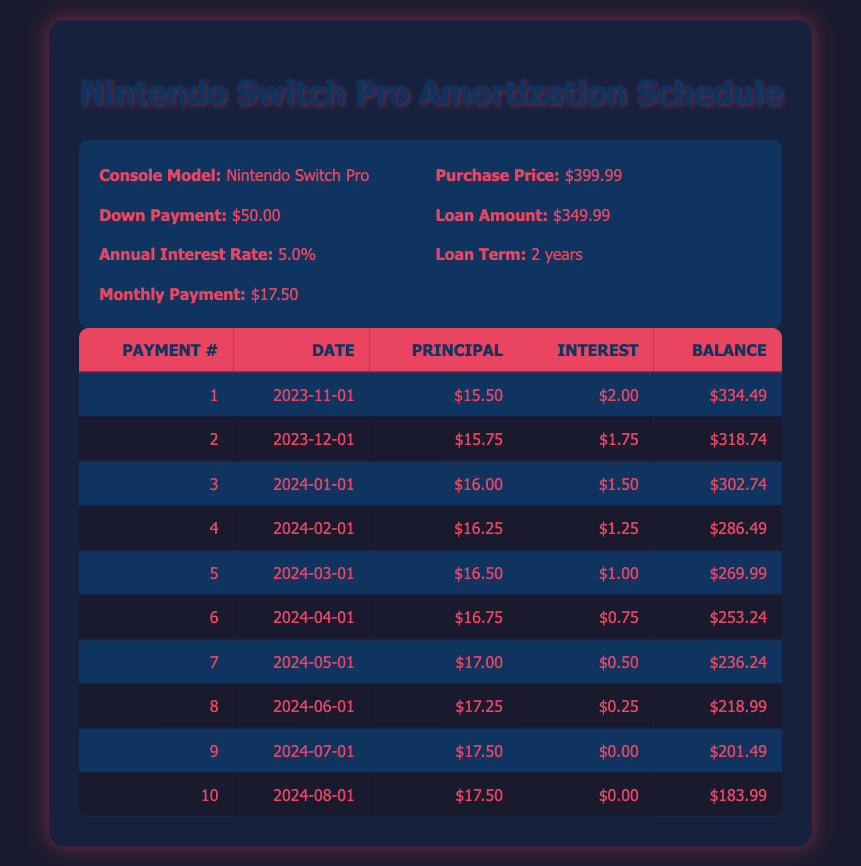What is the total amount paid after the first three payments? To find the total paid after the first three payments, we add the monthly payments together: $17.50 + $17.50 + $17.50 = $52.50.
Answer: 52.50 What is the remaining balance after the second payment? The remaining balance after the second payment is shown in the table. After payment number 2, the remaining balance is $318.74.
Answer: 318.74 Is the principal payment for the fourth payment greater than the principal payment for the first payment? The principal payment for the fourth payment is $16.25, while for the first payment it is $15.50. Since $16.25 is greater than $15.50, the statement is true.
Answer: Yes What is the average principal payment over the first six months? To find the average principal payment, we sum the principal payments of the first six payments ($15.50 + $15.75 + $16.00 + $16.25 + $16.50 + $16.75 = $96.75) and divide by 6 (the number of payments), resulting in an average of $96.75 / 6 = $16.125.
Answer: 16.125 What is the total interest paid after the first payment? The interest paid for the first payment is $2.00. Since this is the only payment considered, the total interest paid after the first payment is simply $2.00.
Answer: 2.00 What is the lowest remaining balance recorded after the first ten payments? By checking the remaining balances for each payment, we find that the lowest balance is recorded after payment number 10, which is $183.99.
Answer: 183.99 Were the interest payments decreasing over the first six months? Reviewing the interest payments for the first six months shows they are decreasing: $2.00, $1.75, $1.50, $1.25, $1.00, $0.75. Since they consistently decrease, the answer is yes.
Answer: Yes How much total principal was paid after the first five payments? To find the total principal paid after the first five payments, we add up the principal payments: $15.50 + $15.75 + $16.00 + $16.25 + $16.50 = $80.00.
Answer: 80.00 